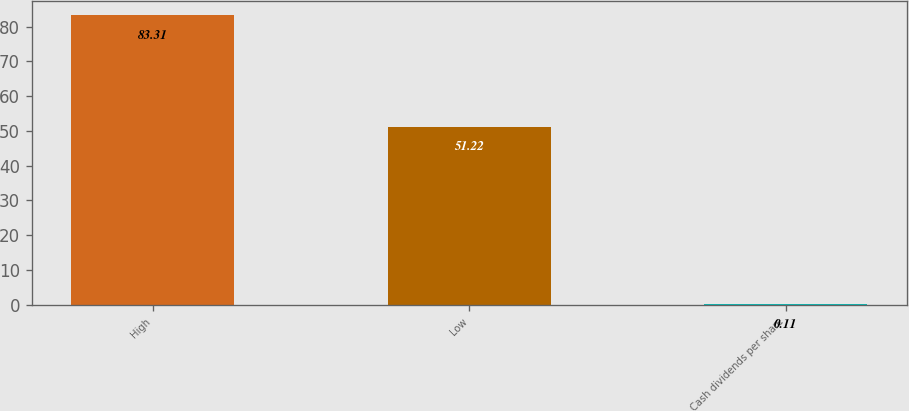<chart> <loc_0><loc_0><loc_500><loc_500><bar_chart><fcel>High<fcel>Low<fcel>Cash dividends per share<nl><fcel>83.31<fcel>51.22<fcel>0.11<nl></chart> 